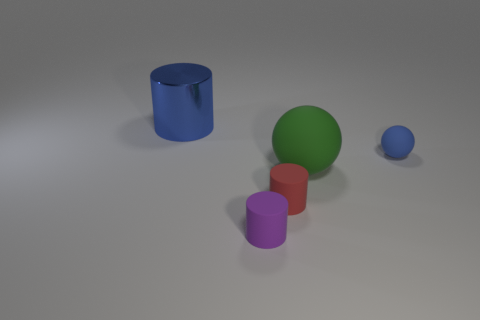Add 2 tiny blue rubber balls. How many objects exist? 7 Subtract all cylinders. How many objects are left? 2 Add 4 large spheres. How many large spheres exist? 5 Subtract 0 gray balls. How many objects are left? 5 Subtract all tiny red rubber objects. Subtract all tiny blue matte objects. How many objects are left? 3 Add 4 large things. How many large things are left? 6 